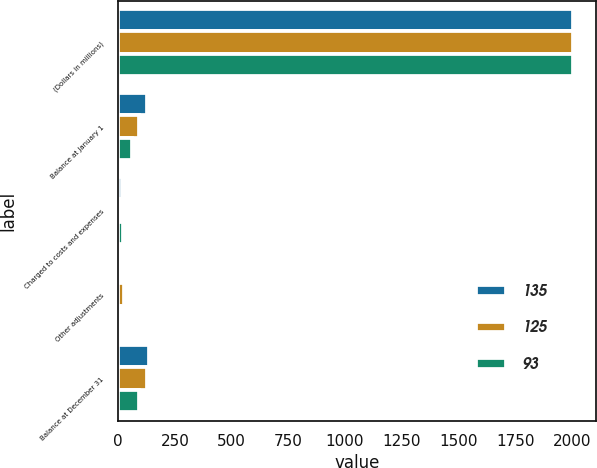Convert chart to OTSL. <chart><loc_0><loc_0><loc_500><loc_500><stacked_bar_chart><ecel><fcel>(Dollars in millions)<fcel>Balance at January 1<fcel>Charged to costs and expenses<fcel>Other adjustments<fcel>Balance at December 31<nl><fcel>135<fcel>2006<fcel>125<fcel>15<fcel>3<fcel>135<nl><fcel>125<fcel>2005<fcel>93<fcel>10<fcel>24<fcel>125<nl><fcel>93<fcel>2004<fcel>63<fcel>21<fcel>9<fcel>93<nl></chart> 